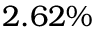<formula> <loc_0><loc_0><loc_500><loc_500>2 . 6 2 \%</formula> 